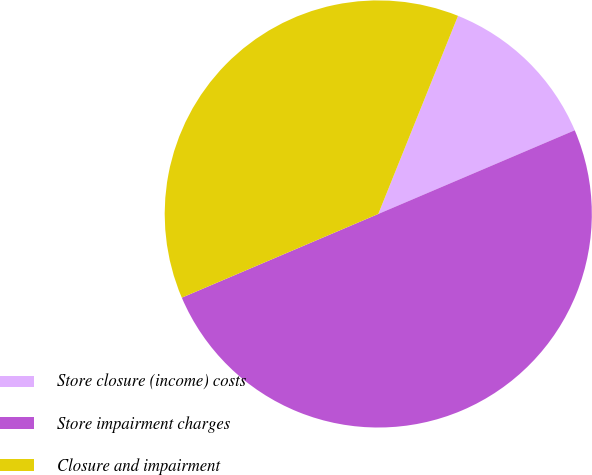Convert chart to OTSL. <chart><loc_0><loc_0><loc_500><loc_500><pie_chart><fcel>Store closure (income) costs<fcel>Store impairment charges<fcel>Closure and impairment<nl><fcel>12.5%<fcel>50.0%<fcel>37.5%<nl></chart> 